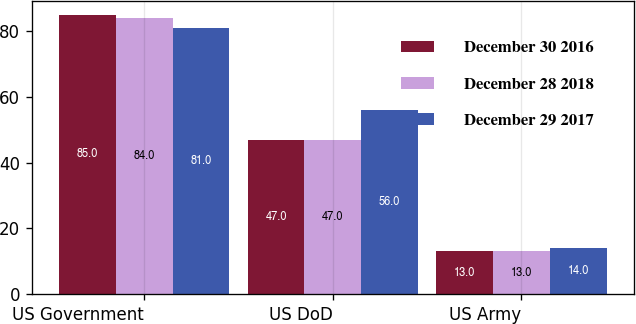<chart> <loc_0><loc_0><loc_500><loc_500><stacked_bar_chart><ecel><fcel>US Government<fcel>US DoD<fcel>US Army<nl><fcel>December 30 2016<fcel>85<fcel>47<fcel>13<nl><fcel>December 28 2018<fcel>84<fcel>47<fcel>13<nl><fcel>December 29 2017<fcel>81<fcel>56<fcel>14<nl></chart> 